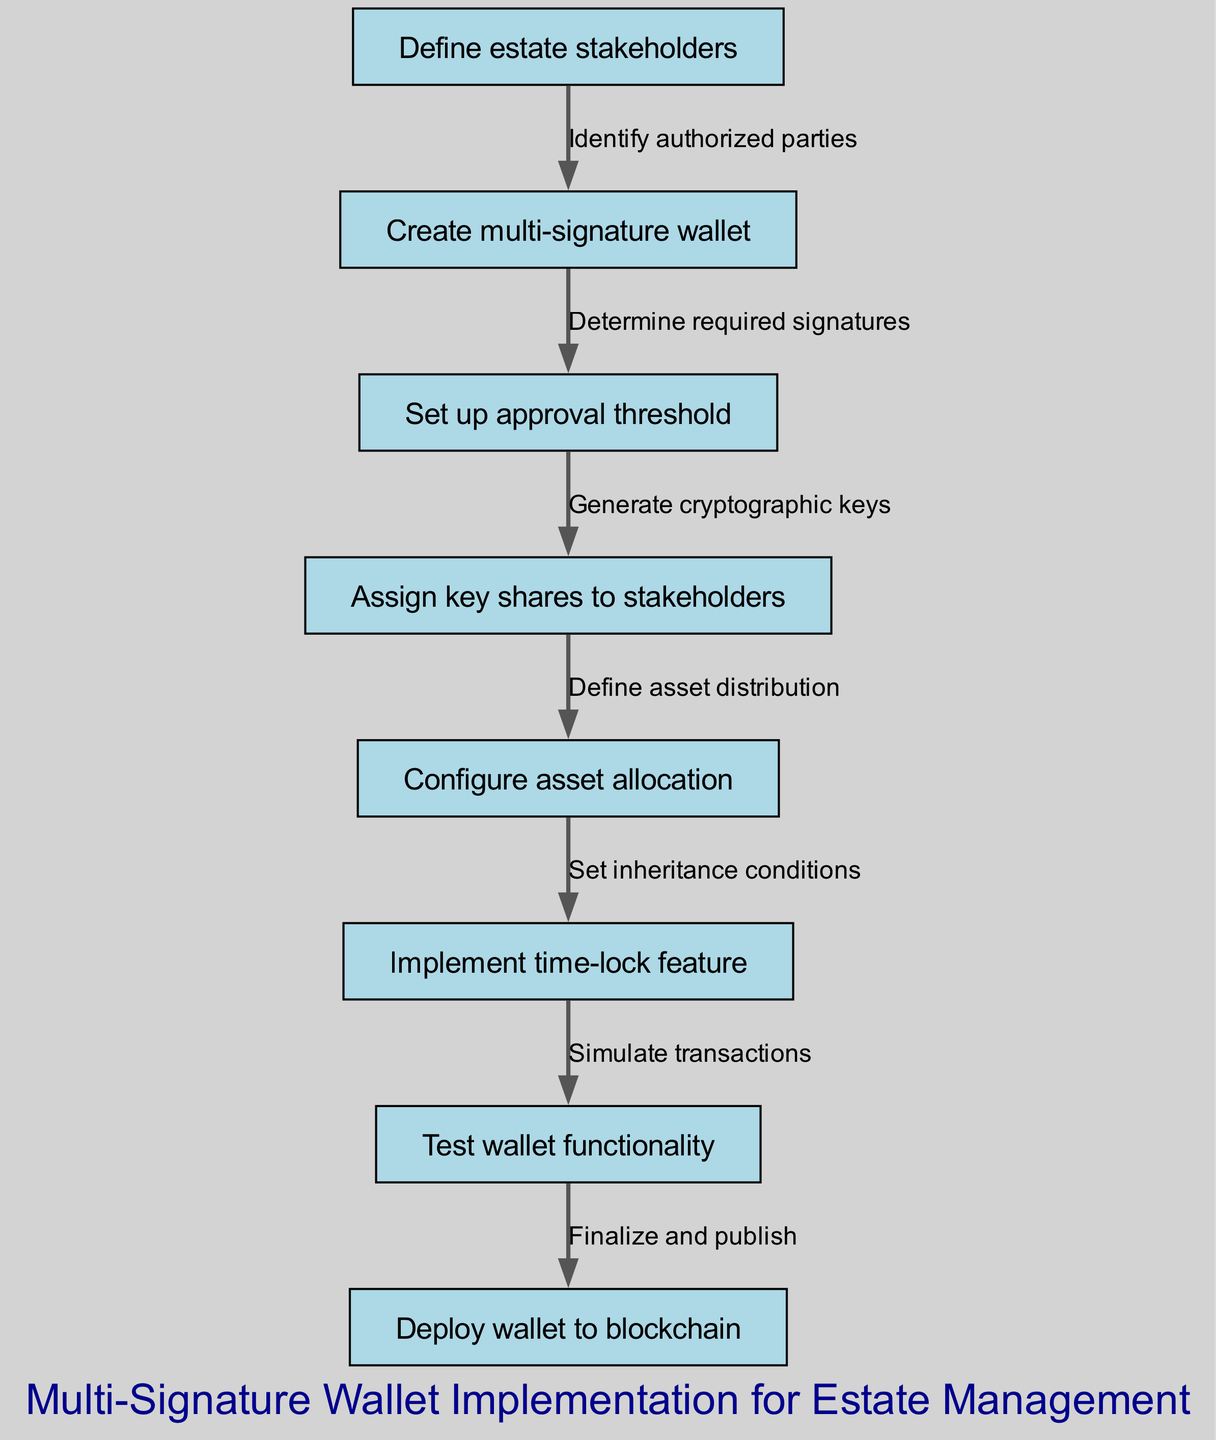What is the first step in the diagram? The diagram begins with the node labeled "Define estate stakeholders," indicating that this is the initial action to be taken in the multi-signature wallet implementation.
Answer: Define estate stakeholders How many nodes are present in the diagram? By counting the unique nodes listed in the data, there are eight nodes that represent steps in the process of implementing a multi-signature wallet.
Answer: 8 What is the last step in the process? The final action in the flow chart is labeled "Deploy wallet to blockchain," which signifies the completion of the multi-signature wallet implementation.
Answer: Deploy wallet to blockchain What action follows the setup of an approval threshold? After "Set up approval threshold," the next step in the flow is "Assign key shares to stakeholders," clearly indicating the flow of actions.
Answer: Assign key shares to stakeholders What condition is established before testing wallet functionality? The implementation of the "time-lock feature" occurs before the step "Test wallet functionality," ensuring that the necessary conditions are in place before testing.
Answer: Implement time-lock feature Which node is directly connected to the "Configure asset allocation" node? The node that follows "Configure asset allocation" is "Implement time-lock feature," which clearly shows its direct connection in the flow of the diagram.
Answer: Implement time-lock feature What does the edge between "Test wallet functionality" and "Deploy wallet to blockchain" indicate? The edge represents the relationship "Finalize and publish," indicating that once testing is complete, the wallet can be finalized and published on the blockchain.
Answer: Finalize and publish What follows after assigning key shares to stakeholders? The subsequent step after "Assign key shares to stakeholders" is "Configure asset allocation," which is dependent on the completion of assigning key shares.
Answer: Configure asset allocation 